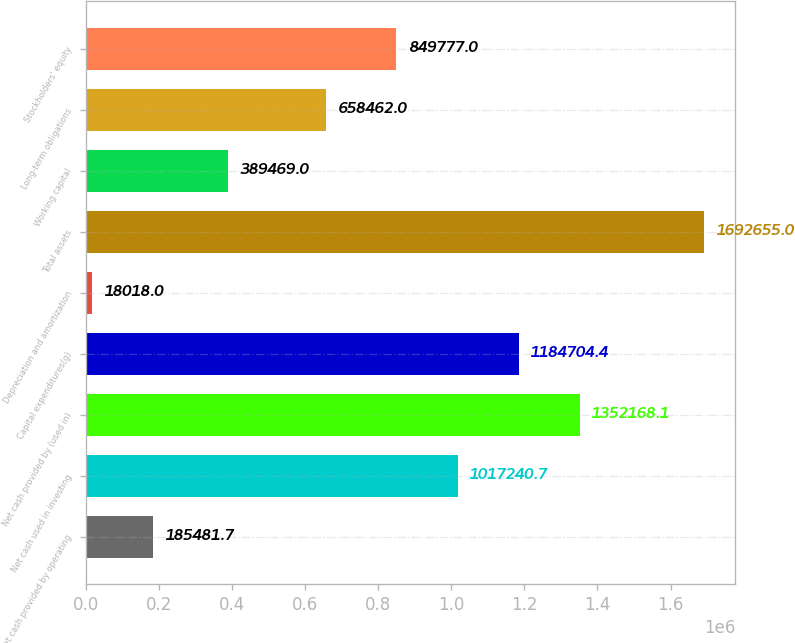Convert chart to OTSL. <chart><loc_0><loc_0><loc_500><loc_500><bar_chart><fcel>Net cash provided by operating<fcel>Net cash used in investing<fcel>Net cash provided by (used in)<fcel>Capital expenditures(g)<fcel>Depreciation and amortization<fcel>Total assets<fcel>Working capital<fcel>Long-term obligations<fcel>Stockholders' equity<nl><fcel>185482<fcel>1.01724e+06<fcel>1.35217e+06<fcel>1.1847e+06<fcel>18018<fcel>1.69266e+06<fcel>389469<fcel>658462<fcel>849777<nl></chart> 